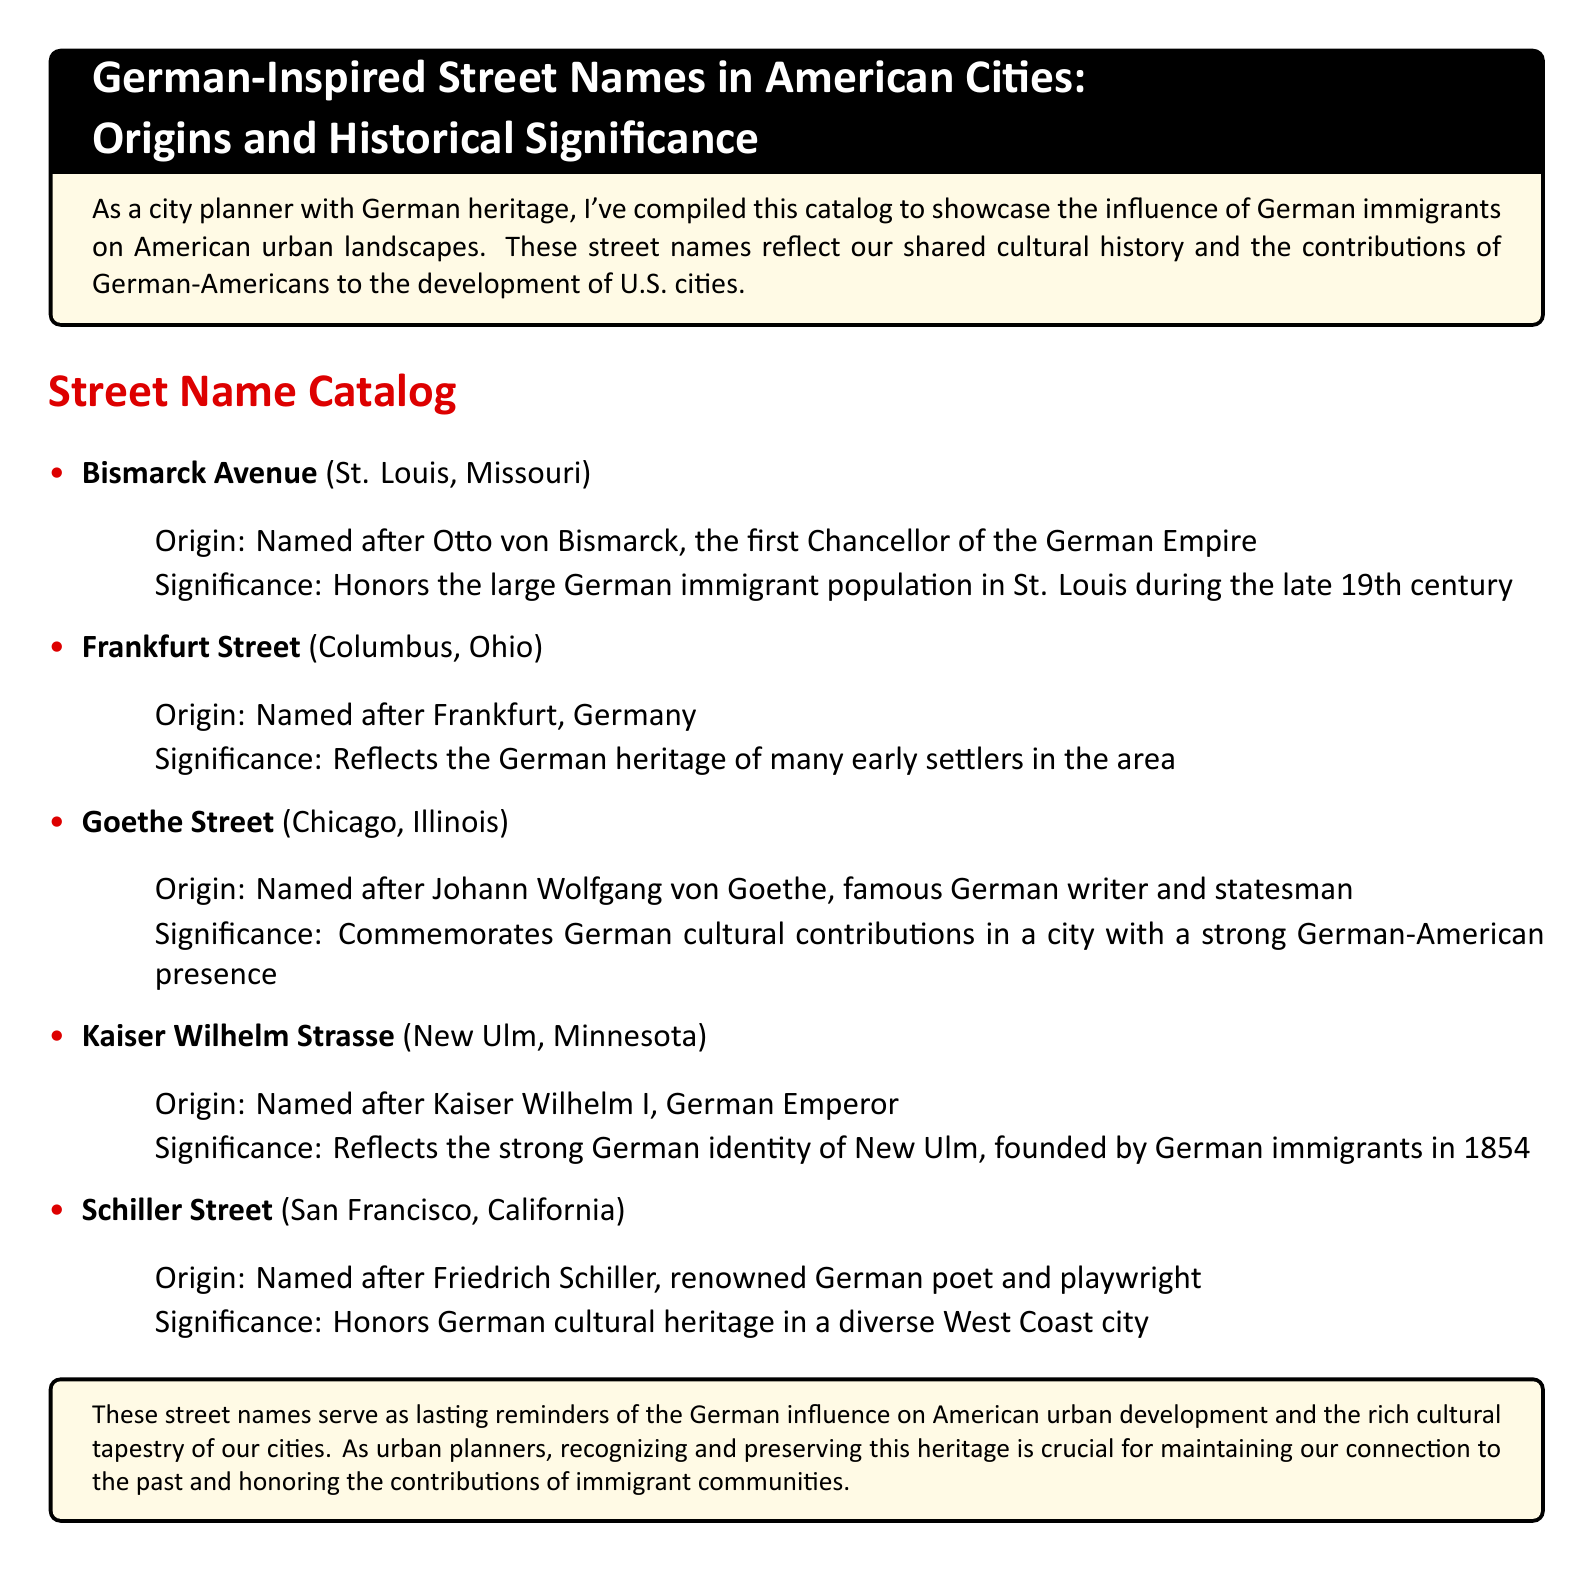What is the origin of Bismarck Avenue? Bismarck Avenue is named after Otto von Bismarck, the first Chancellor of the German Empire.
Answer: Otto von Bismarck What city has a Frankfurt Street? Frankfurt Street is located in Columbus, Ohio.
Answer: Columbus, Ohio Who is Goethe Street named after? Goethe Street is named after Johann Wolfgang von Goethe, a famous German writer and statesman.
Answer: Johann Wolfgang von Goethe What is the significance of Kaiser Wilhelm Strasse? Kaiser Wilhelm Strasse reflects the strong German identity of New Ulm, founded by German immigrants in 1854.
Answer: Strong German identity Which street honors a German poet and playwright? Schiller Street honors Friedrich Schiller.
Answer: Schiller Street How many street names are listed in the catalog? The catalog lists five street names.
Answer: Five What is the color of the box that contains the street name catalog? The box that contains the street name catalog has a background color of yellow.
Answer: Yellow What does the document emphasize about German influence? The document emphasizes the lasting reminders of German influence on American urban development.
Answer: Lasting reminders 